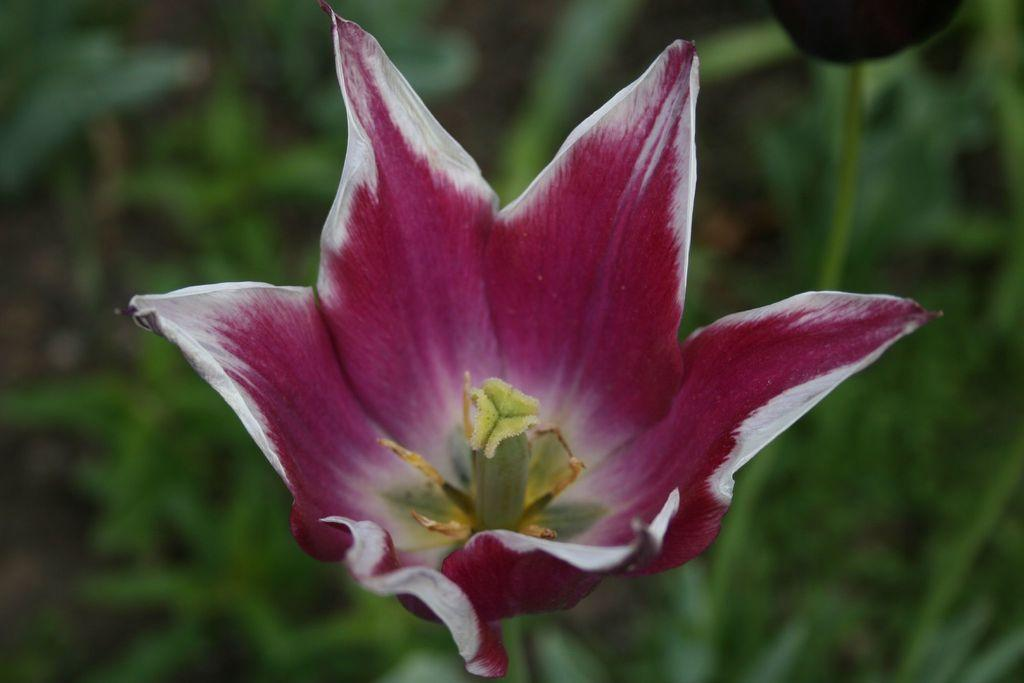What is the main subject of the image? There is a flower in the center of the image. What color is the flower? The flower is purple. What else can be seen at the bottom of the image? There are plants at the bottom of the image. How many times has the flower celebrated its birthday in the image? There is no indication of a flower's birthday in the image, as flowers do not celebrate birthdays. 